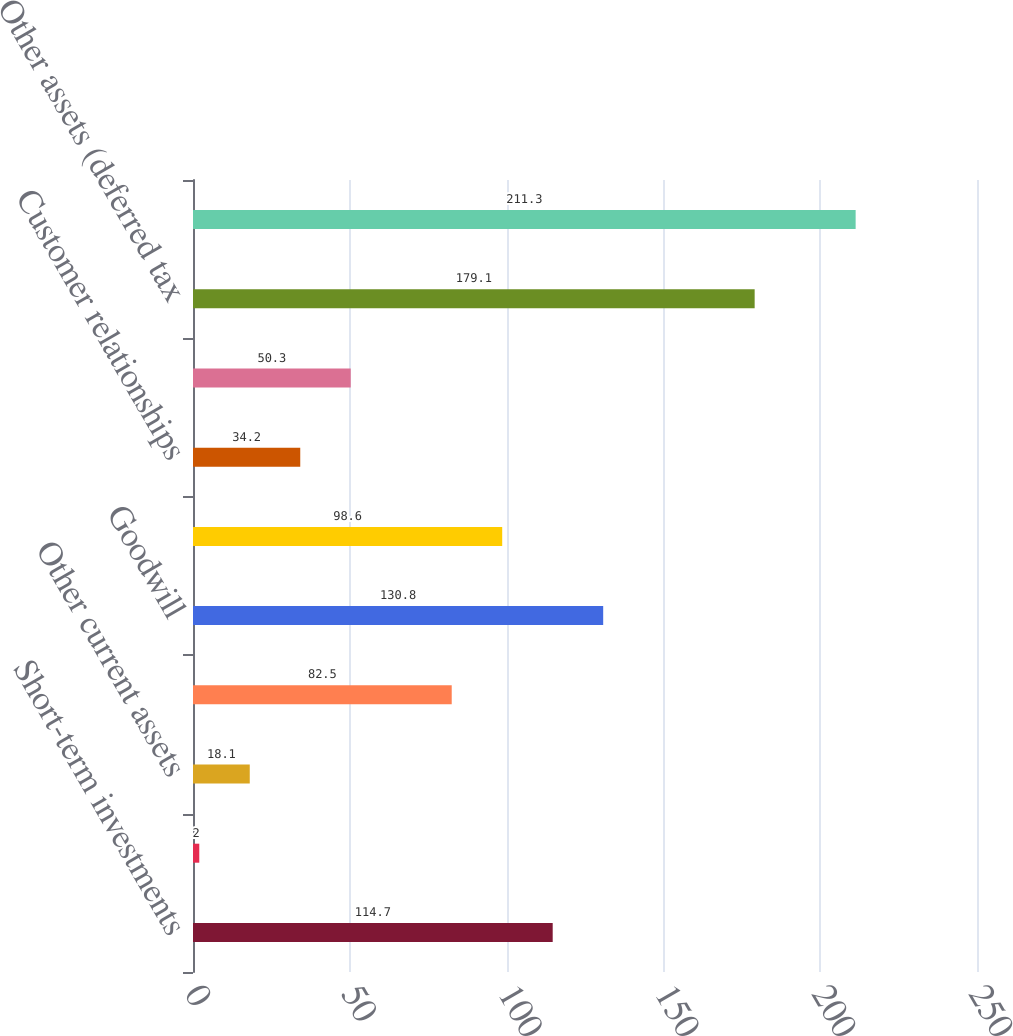Convert chart to OTSL. <chart><loc_0><loc_0><loc_500><loc_500><bar_chart><fcel>Short-term investments<fcel>Receivables<fcel>Other current assets<fcel>Property and equipment<fcel>Goodwill<fcel>Tradenames<fcel>Customer relationships<fcel>Equity and other investments<fcel>Other assets (deferred tax<fcel>Total assets<nl><fcel>114.7<fcel>2<fcel>18.1<fcel>82.5<fcel>130.8<fcel>98.6<fcel>34.2<fcel>50.3<fcel>179.1<fcel>211.3<nl></chart> 